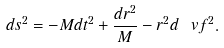Convert formula to latex. <formula><loc_0><loc_0><loc_500><loc_500>d s ^ { 2 } = - M d t ^ { 2 } + \frac { d r ^ { 2 } } M - r ^ { 2 } d \ v f ^ { 2 } .</formula> 